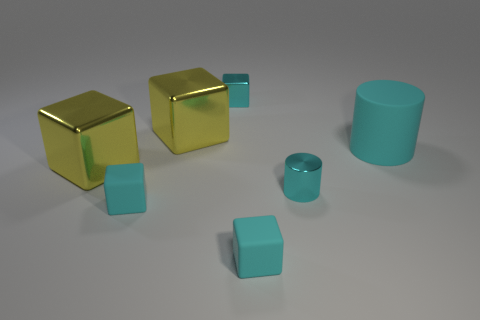Subtract all small cubes. How many cubes are left? 2 Add 1 tiny cyan cylinders. How many objects exist? 8 Subtract all yellow blocks. How many blocks are left? 3 Subtract 2 blocks. How many blocks are left? 3 Subtract all purple balls. How many cyan blocks are left? 3 Subtract all cylinders. How many objects are left? 5 Subtract all brown blocks. Subtract all blue cylinders. How many blocks are left? 5 Subtract all large cyan objects. Subtract all yellow shiny objects. How many objects are left? 4 Add 1 large yellow cubes. How many large yellow cubes are left? 3 Add 4 matte blocks. How many matte blocks exist? 6 